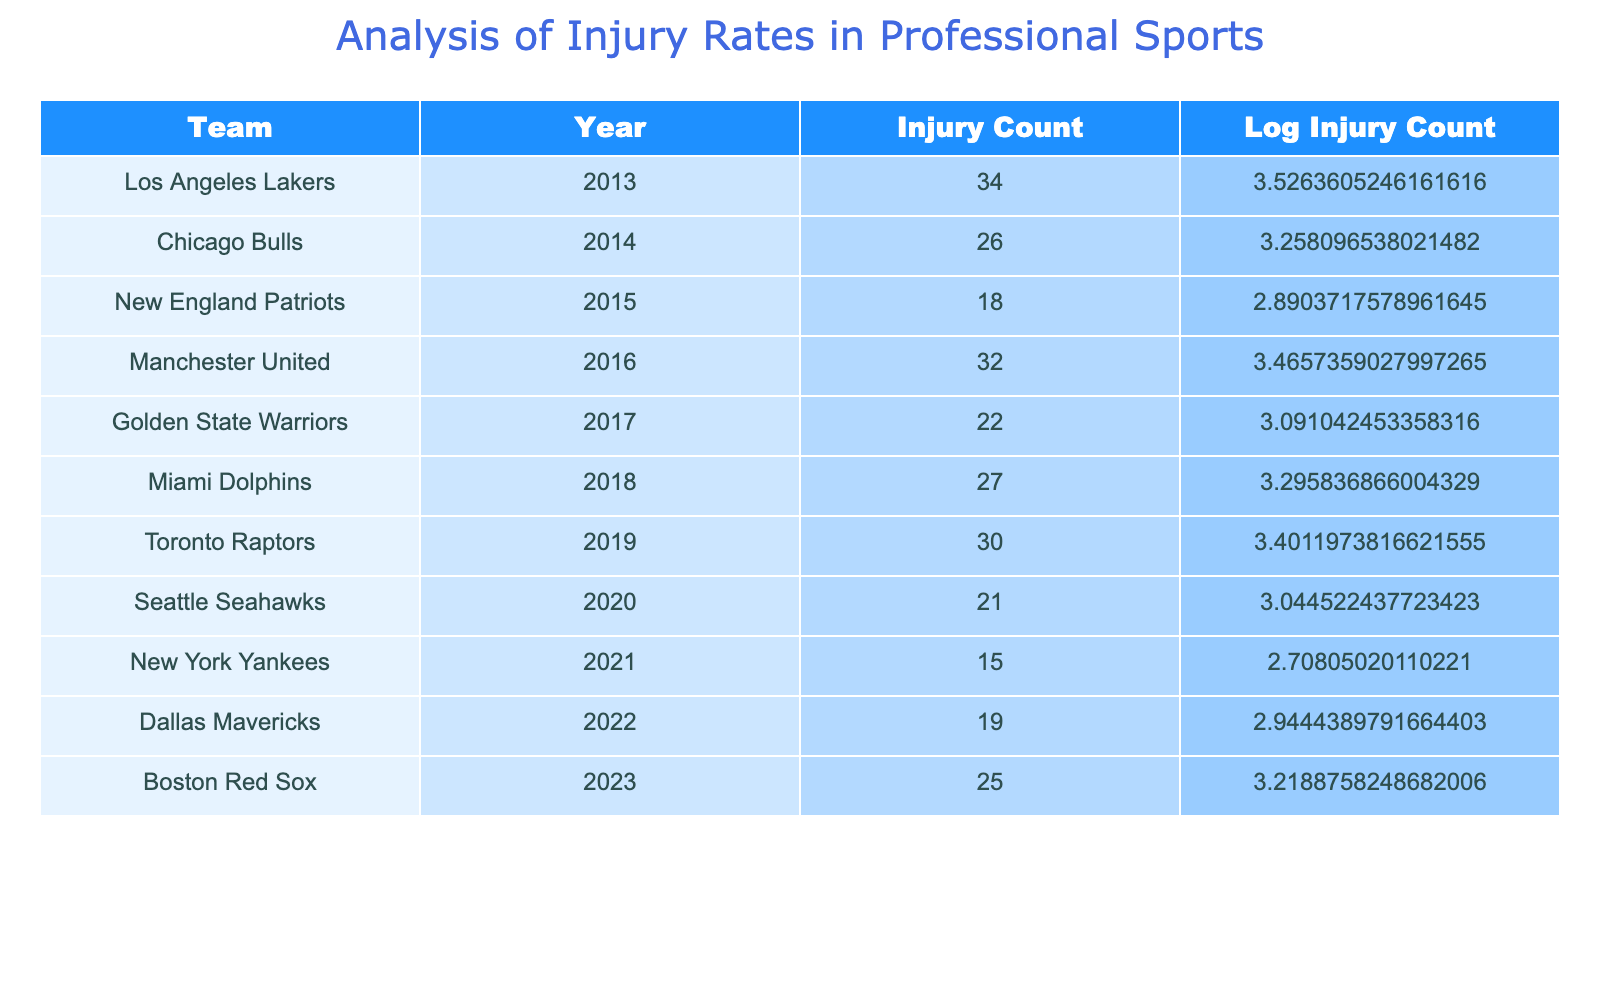What is the injury count for the New England Patriots in 2015? The table shows that the injury count for the New England Patriots in 2015 is listed under the respective year, which directly corresponds to the value in the Injury Count column. According to the data, it is 18.
Answer: 18 Which team had the highest injury count in the provided data? By comparing the injury counts across all teams in the table, the highest value can be found. The Los Angeles Lakers had an injury count of 34, which is greater than any other team's count.
Answer: Los Angeles Lakers What is the average injury count across all teams? To find the average, we sum the injury counts: 34 + 26 + 18 + 32 + 22 + 27 + 30 + 21 + 15 + 19 + 25 =  339. There are 11 teams, so we divide this sum by 11 to get the average: 339 / 11 = 30.82 (approximately, rounded to two decimal places).
Answer: 30.82 Did any team have an injury count of 15 or lower? We check the Injury Count column for values less than or equal to 15. The New York Yankees exhibit an injury count of 15, confirming that at least one team meets this criterion.
Answer: Yes What is the difference in injury counts between the Los Angeles Lakers and the Dallas Mavericks? The Los Angeles Lakers have an injury count of 34, while the Dallas Mavericks have 19. To find the difference, we subtract the Mavericks' count from the Lakers': 34 - 19 = 15.
Answer: 15 Which year had the lowest injury count, and what was the count? The year with the lowest injury count is determined by examining all injury counts in the table. The New York Yankees in 2021 had the lowest injury count of 15.
Answer: 2021, 15 Is the injury count for the Miami Dolphins greater than the average injury count? The average injury count is calculated as previously described (30.82). The Miami Dolphins have an injury count of 27, which is less than the average, so the answer is based on this comparison.
Answer: No Which two teams had a combined injury count of 50 or more? We check combinations of teams to find two whose injury counts sum to 50 or more. The Los Angeles Lakers (34) and the Chicago Bulls (26) provide a sum of 60, and other combinations can be checked as well. Since this pair works, we can conclude.
Answer: Yes 